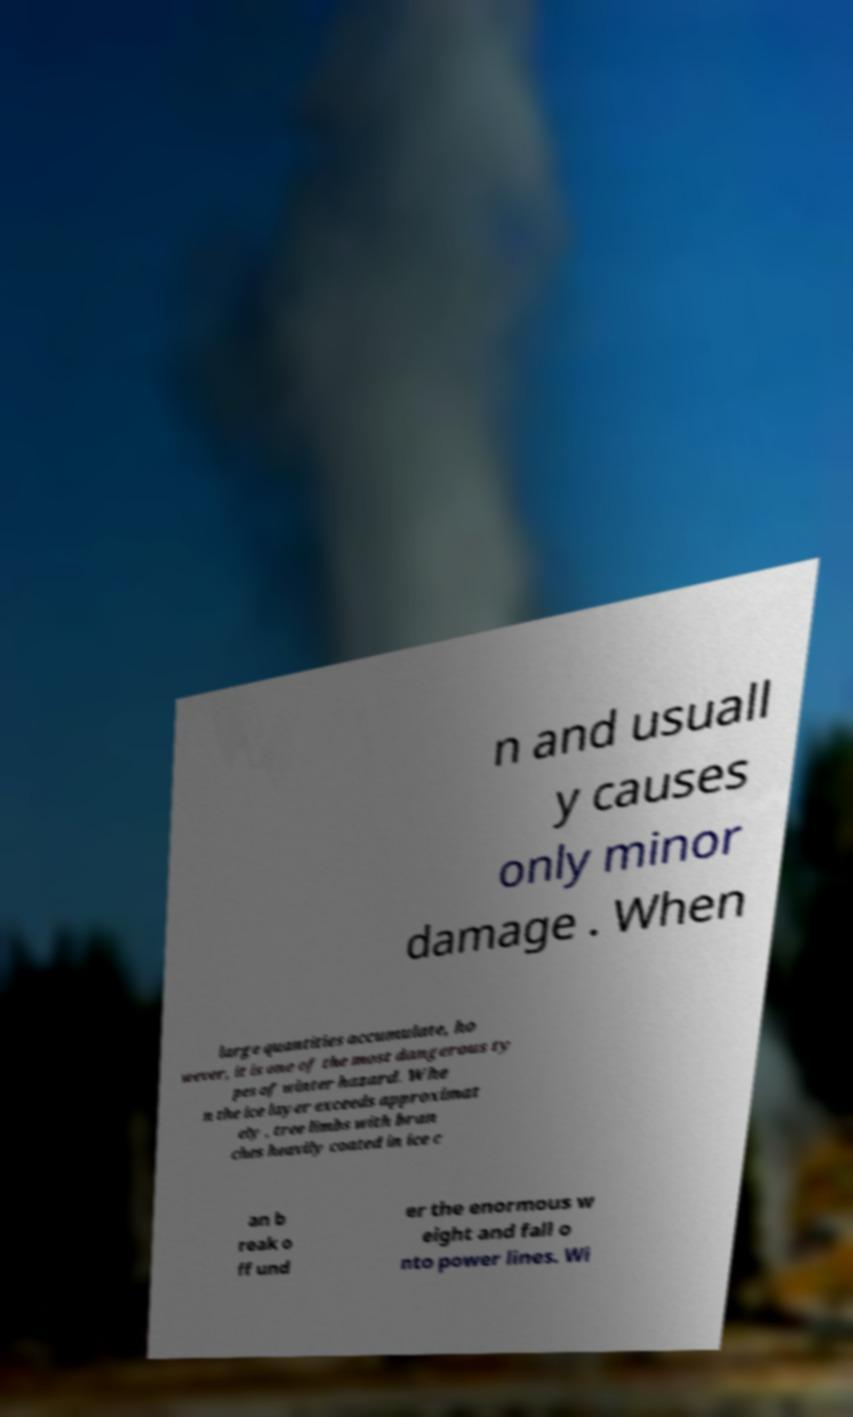Please read and relay the text visible in this image. What does it say? n and usuall y causes only minor damage . When large quantities accumulate, ho wever, it is one of the most dangerous ty pes of winter hazard. Whe n the ice layer exceeds approximat ely , tree limbs with bran ches heavily coated in ice c an b reak o ff und er the enormous w eight and fall o nto power lines. Wi 